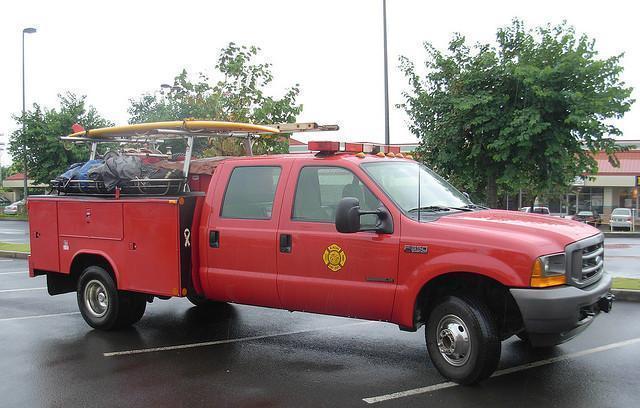What is this vehicle used for?
Answer the question by selecting the correct answer among the 4 following choices.
Options: Hauling, construction, emergencies, passengers. Emergencies. 